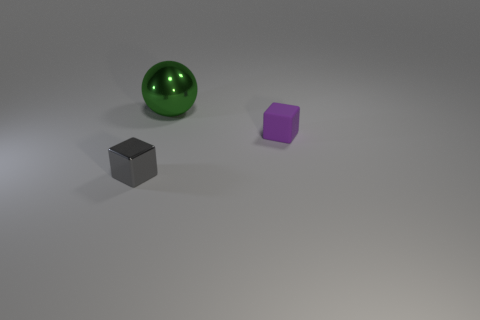Subtract all yellow cubes. Subtract all yellow balls. How many cubes are left? 2 Add 3 green matte blocks. How many objects exist? 6 Subtract all cubes. How many objects are left? 1 Add 3 green shiny spheres. How many green shiny spheres exist? 4 Subtract 0 yellow spheres. How many objects are left? 3 Subtract all gray metallic balls. Subtract all blocks. How many objects are left? 1 Add 1 green objects. How many green objects are left? 2 